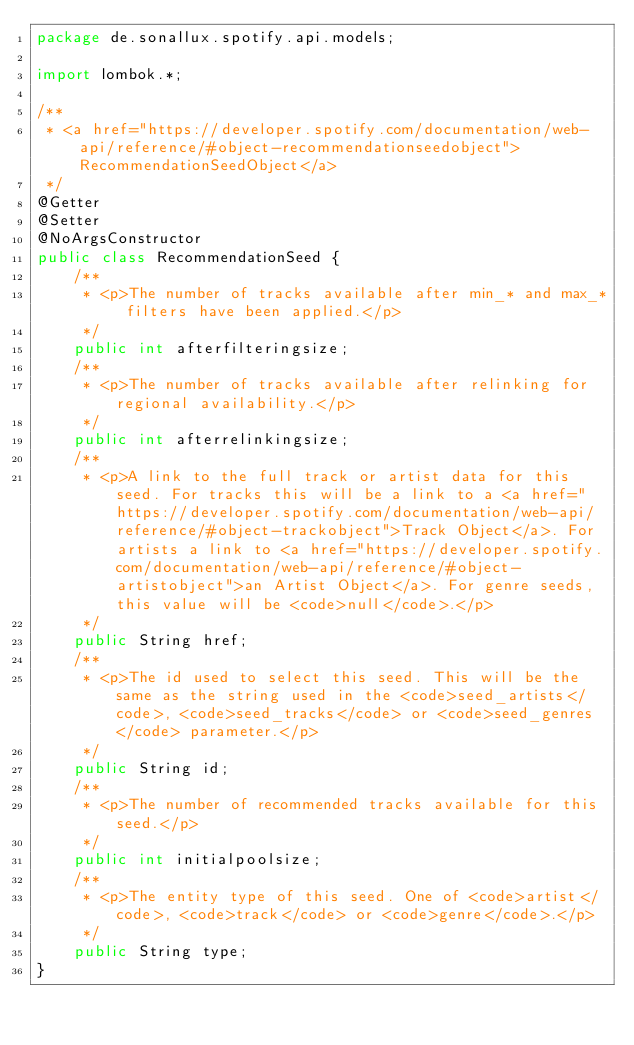Convert code to text. <code><loc_0><loc_0><loc_500><loc_500><_Java_>package de.sonallux.spotify.api.models;

import lombok.*;

/**
 * <a href="https://developer.spotify.com/documentation/web-api/reference/#object-recommendationseedobject">RecommendationSeedObject</a>
 */
@Getter
@Setter
@NoArgsConstructor
public class RecommendationSeed {
    /**
     * <p>The number of tracks available after min_* and max_* filters have been applied.</p>
     */
    public int afterfilteringsize;
    /**
     * <p>The number of tracks available after relinking for regional availability.</p>
     */
    public int afterrelinkingsize;
    /**
     * <p>A link to the full track or artist data for this seed. For tracks this will be a link to a <a href="https://developer.spotify.com/documentation/web-api/reference/#object-trackobject">Track Object</a>. For artists a link to <a href="https://developer.spotify.com/documentation/web-api/reference/#object-artistobject">an Artist Object</a>. For genre seeds, this value will be <code>null</code>.</p>
     */
    public String href;
    /**
     * <p>The id used to select this seed. This will be the same as the string used in the <code>seed_artists</code>, <code>seed_tracks</code> or <code>seed_genres</code> parameter.</p>
     */
    public String id;
    /**
     * <p>The number of recommended tracks available for this seed.</p>
     */
    public int initialpoolsize;
    /**
     * <p>The entity type of this seed. One of <code>artist</code>, <code>track</code> or <code>genre</code>.</p>
     */
    public String type;
}
</code> 